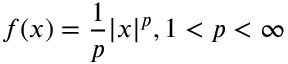<formula> <loc_0><loc_0><loc_500><loc_500>f ( x ) = { \frac { 1 } { p } } | x | ^ { p } , 1 < p < \infty</formula> 